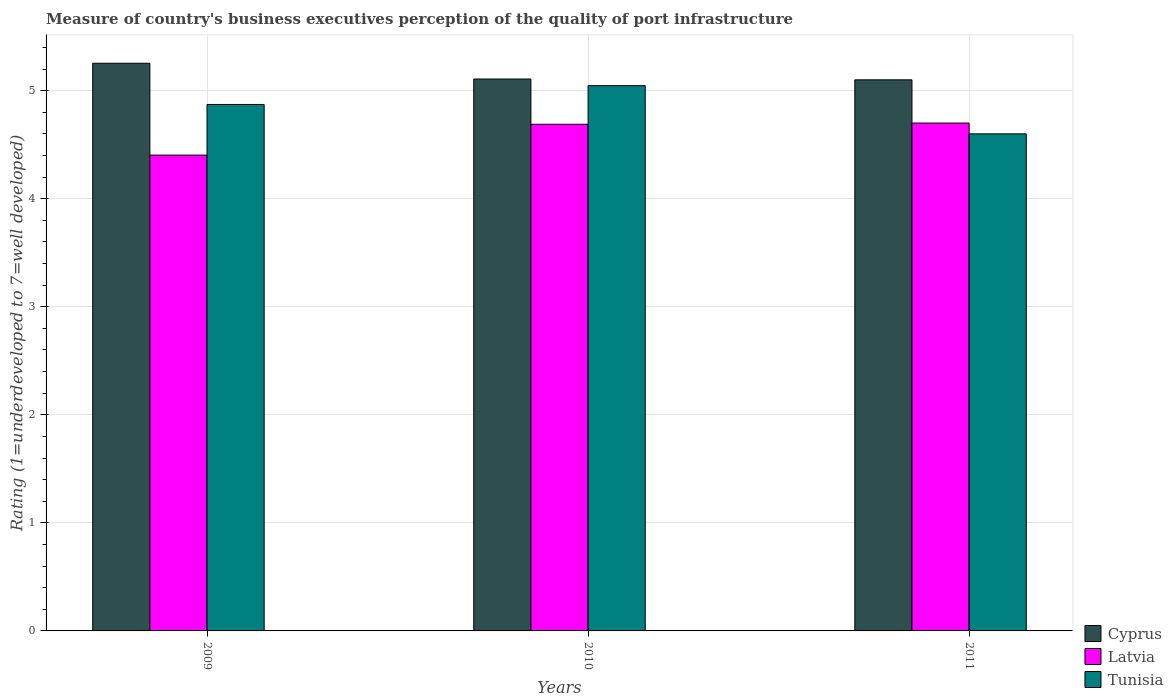How many different coloured bars are there?
Keep it short and to the point. 3. How many bars are there on the 3rd tick from the right?
Provide a short and direct response. 3. What is the ratings of the quality of port infrastructure in Latvia in 2010?
Your response must be concise. 4.69. Across all years, what is the maximum ratings of the quality of port infrastructure in Tunisia?
Your answer should be very brief. 5.05. Across all years, what is the minimum ratings of the quality of port infrastructure in Tunisia?
Make the answer very short. 4.6. In which year was the ratings of the quality of port infrastructure in Tunisia maximum?
Provide a short and direct response. 2010. What is the total ratings of the quality of port infrastructure in Latvia in the graph?
Your response must be concise. 13.79. What is the difference between the ratings of the quality of port infrastructure in Tunisia in 2010 and that in 2011?
Provide a succinct answer. 0.45. What is the difference between the ratings of the quality of port infrastructure in Latvia in 2011 and the ratings of the quality of port infrastructure in Tunisia in 2009?
Offer a very short reply. -0.17. What is the average ratings of the quality of port infrastructure in Cyprus per year?
Give a very brief answer. 5.15. In the year 2009, what is the difference between the ratings of the quality of port infrastructure in Tunisia and ratings of the quality of port infrastructure in Cyprus?
Your response must be concise. -0.38. In how many years, is the ratings of the quality of port infrastructure in Cyprus greater than 4.8?
Your answer should be very brief. 3. What is the ratio of the ratings of the quality of port infrastructure in Tunisia in 2009 to that in 2011?
Make the answer very short. 1.06. Is the ratings of the quality of port infrastructure in Cyprus in 2009 less than that in 2011?
Keep it short and to the point. No. Is the difference between the ratings of the quality of port infrastructure in Tunisia in 2009 and 2010 greater than the difference between the ratings of the quality of port infrastructure in Cyprus in 2009 and 2010?
Provide a short and direct response. No. What is the difference between the highest and the second highest ratings of the quality of port infrastructure in Latvia?
Offer a very short reply. 0.01. What is the difference between the highest and the lowest ratings of the quality of port infrastructure in Latvia?
Provide a succinct answer. 0.3. What does the 2nd bar from the left in 2011 represents?
Offer a terse response. Latvia. What does the 3rd bar from the right in 2010 represents?
Your answer should be compact. Cyprus. How many years are there in the graph?
Ensure brevity in your answer.  3. Does the graph contain grids?
Your response must be concise. Yes. How many legend labels are there?
Offer a terse response. 3. What is the title of the graph?
Your response must be concise. Measure of country's business executives perception of the quality of port infrastructure. What is the label or title of the Y-axis?
Ensure brevity in your answer.  Rating (1=underdeveloped to 7=well developed). What is the Rating (1=underdeveloped to 7=well developed) of Cyprus in 2009?
Keep it short and to the point. 5.25. What is the Rating (1=underdeveloped to 7=well developed) in Latvia in 2009?
Offer a very short reply. 4.4. What is the Rating (1=underdeveloped to 7=well developed) of Tunisia in 2009?
Your response must be concise. 4.87. What is the Rating (1=underdeveloped to 7=well developed) of Cyprus in 2010?
Make the answer very short. 5.11. What is the Rating (1=underdeveloped to 7=well developed) in Latvia in 2010?
Keep it short and to the point. 4.69. What is the Rating (1=underdeveloped to 7=well developed) in Tunisia in 2010?
Your answer should be very brief. 5.05. What is the Rating (1=underdeveloped to 7=well developed) in Cyprus in 2011?
Ensure brevity in your answer.  5.1. What is the Rating (1=underdeveloped to 7=well developed) in Tunisia in 2011?
Keep it short and to the point. 4.6. Across all years, what is the maximum Rating (1=underdeveloped to 7=well developed) in Cyprus?
Your response must be concise. 5.25. Across all years, what is the maximum Rating (1=underdeveloped to 7=well developed) of Tunisia?
Offer a terse response. 5.05. Across all years, what is the minimum Rating (1=underdeveloped to 7=well developed) in Latvia?
Make the answer very short. 4.4. What is the total Rating (1=underdeveloped to 7=well developed) of Cyprus in the graph?
Keep it short and to the point. 15.46. What is the total Rating (1=underdeveloped to 7=well developed) of Latvia in the graph?
Keep it short and to the point. 13.79. What is the total Rating (1=underdeveloped to 7=well developed) of Tunisia in the graph?
Ensure brevity in your answer.  14.52. What is the difference between the Rating (1=underdeveloped to 7=well developed) in Cyprus in 2009 and that in 2010?
Ensure brevity in your answer.  0.15. What is the difference between the Rating (1=underdeveloped to 7=well developed) in Latvia in 2009 and that in 2010?
Provide a succinct answer. -0.29. What is the difference between the Rating (1=underdeveloped to 7=well developed) of Tunisia in 2009 and that in 2010?
Offer a very short reply. -0.17. What is the difference between the Rating (1=underdeveloped to 7=well developed) of Cyprus in 2009 and that in 2011?
Ensure brevity in your answer.  0.15. What is the difference between the Rating (1=underdeveloped to 7=well developed) in Latvia in 2009 and that in 2011?
Offer a terse response. -0.3. What is the difference between the Rating (1=underdeveloped to 7=well developed) of Tunisia in 2009 and that in 2011?
Keep it short and to the point. 0.27. What is the difference between the Rating (1=underdeveloped to 7=well developed) in Cyprus in 2010 and that in 2011?
Provide a succinct answer. 0.01. What is the difference between the Rating (1=underdeveloped to 7=well developed) in Latvia in 2010 and that in 2011?
Your answer should be very brief. -0.01. What is the difference between the Rating (1=underdeveloped to 7=well developed) of Tunisia in 2010 and that in 2011?
Offer a terse response. 0.45. What is the difference between the Rating (1=underdeveloped to 7=well developed) of Cyprus in 2009 and the Rating (1=underdeveloped to 7=well developed) of Latvia in 2010?
Offer a very short reply. 0.56. What is the difference between the Rating (1=underdeveloped to 7=well developed) of Cyprus in 2009 and the Rating (1=underdeveloped to 7=well developed) of Tunisia in 2010?
Your response must be concise. 0.21. What is the difference between the Rating (1=underdeveloped to 7=well developed) of Latvia in 2009 and the Rating (1=underdeveloped to 7=well developed) of Tunisia in 2010?
Keep it short and to the point. -0.64. What is the difference between the Rating (1=underdeveloped to 7=well developed) in Cyprus in 2009 and the Rating (1=underdeveloped to 7=well developed) in Latvia in 2011?
Your response must be concise. 0.55. What is the difference between the Rating (1=underdeveloped to 7=well developed) of Cyprus in 2009 and the Rating (1=underdeveloped to 7=well developed) of Tunisia in 2011?
Your response must be concise. 0.65. What is the difference between the Rating (1=underdeveloped to 7=well developed) of Latvia in 2009 and the Rating (1=underdeveloped to 7=well developed) of Tunisia in 2011?
Offer a very short reply. -0.2. What is the difference between the Rating (1=underdeveloped to 7=well developed) of Cyprus in 2010 and the Rating (1=underdeveloped to 7=well developed) of Latvia in 2011?
Your answer should be compact. 0.41. What is the difference between the Rating (1=underdeveloped to 7=well developed) in Cyprus in 2010 and the Rating (1=underdeveloped to 7=well developed) in Tunisia in 2011?
Keep it short and to the point. 0.51. What is the difference between the Rating (1=underdeveloped to 7=well developed) in Latvia in 2010 and the Rating (1=underdeveloped to 7=well developed) in Tunisia in 2011?
Make the answer very short. 0.09. What is the average Rating (1=underdeveloped to 7=well developed) of Cyprus per year?
Make the answer very short. 5.15. What is the average Rating (1=underdeveloped to 7=well developed) of Latvia per year?
Your answer should be very brief. 4.6. What is the average Rating (1=underdeveloped to 7=well developed) in Tunisia per year?
Give a very brief answer. 4.84. In the year 2009, what is the difference between the Rating (1=underdeveloped to 7=well developed) of Cyprus and Rating (1=underdeveloped to 7=well developed) of Latvia?
Make the answer very short. 0.85. In the year 2009, what is the difference between the Rating (1=underdeveloped to 7=well developed) of Cyprus and Rating (1=underdeveloped to 7=well developed) of Tunisia?
Your answer should be compact. 0.38. In the year 2009, what is the difference between the Rating (1=underdeveloped to 7=well developed) of Latvia and Rating (1=underdeveloped to 7=well developed) of Tunisia?
Give a very brief answer. -0.47. In the year 2010, what is the difference between the Rating (1=underdeveloped to 7=well developed) of Cyprus and Rating (1=underdeveloped to 7=well developed) of Latvia?
Your answer should be very brief. 0.42. In the year 2010, what is the difference between the Rating (1=underdeveloped to 7=well developed) of Cyprus and Rating (1=underdeveloped to 7=well developed) of Tunisia?
Offer a very short reply. 0.06. In the year 2010, what is the difference between the Rating (1=underdeveloped to 7=well developed) of Latvia and Rating (1=underdeveloped to 7=well developed) of Tunisia?
Provide a succinct answer. -0.36. In the year 2011, what is the difference between the Rating (1=underdeveloped to 7=well developed) in Cyprus and Rating (1=underdeveloped to 7=well developed) in Tunisia?
Provide a succinct answer. 0.5. In the year 2011, what is the difference between the Rating (1=underdeveloped to 7=well developed) of Latvia and Rating (1=underdeveloped to 7=well developed) of Tunisia?
Your answer should be compact. 0.1. What is the ratio of the Rating (1=underdeveloped to 7=well developed) of Cyprus in 2009 to that in 2010?
Give a very brief answer. 1.03. What is the ratio of the Rating (1=underdeveloped to 7=well developed) of Latvia in 2009 to that in 2010?
Your answer should be very brief. 0.94. What is the ratio of the Rating (1=underdeveloped to 7=well developed) of Tunisia in 2009 to that in 2010?
Provide a short and direct response. 0.97. What is the ratio of the Rating (1=underdeveloped to 7=well developed) in Cyprus in 2009 to that in 2011?
Offer a terse response. 1.03. What is the ratio of the Rating (1=underdeveloped to 7=well developed) in Latvia in 2009 to that in 2011?
Your answer should be compact. 0.94. What is the ratio of the Rating (1=underdeveloped to 7=well developed) in Tunisia in 2009 to that in 2011?
Make the answer very short. 1.06. What is the ratio of the Rating (1=underdeveloped to 7=well developed) in Cyprus in 2010 to that in 2011?
Provide a succinct answer. 1. What is the ratio of the Rating (1=underdeveloped to 7=well developed) in Latvia in 2010 to that in 2011?
Make the answer very short. 1. What is the ratio of the Rating (1=underdeveloped to 7=well developed) of Tunisia in 2010 to that in 2011?
Offer a terse response. 1.1. What is the difference between the highest and the second highest Rating (1=underdeveloped to 7=well developed) of Cyprus?
Offer a very short reply. 0.15. What is the difference between the highest and the second highest Rating (1=underdeveloped to 7=well developed) in Latvia?
Provide a short and direct response. 0.01. What is the difference between the highest and the second highest Rating (1=underdeveloped to 7=well developed) in Tunisia?
Make the answer very short. 0.17. What is the difference between the highest and the lowest Rating (1=underdeveloped to 7=well developed) of Cyprus?
Provide a succinct answer. 0.15. What is the difference between the highest and the lowest Rating (1=underdeveloped to 7=well developed) in Latvia?
Provide a succinct answer. 0.3. What is the difference between the highest and the lowest Rating (1=underdeveloped to 7=well developed) of Tunisia?
Provide a succinct answer. 0.45. 